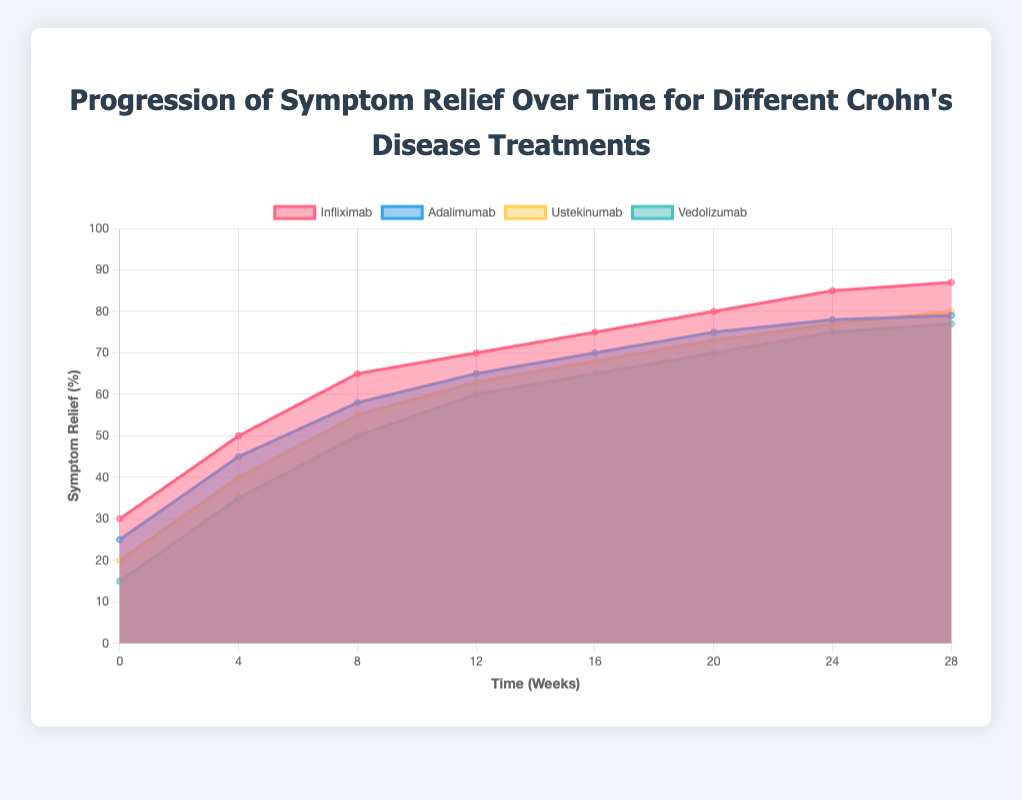What is the title of the figure? The title of the figure is displayed at the top of the chart.
Answer: "Progression of Symptom Relief Over Time for Different Crohn's Disease Treatments" Which treatment shows the highest symptom relief at week 28? By looking at the values at week 28 for all treatments, Infliximab shows the highest symptom relief.
Answer: Infliximab How many weeks are represented on the x-axis? The x-axis lists the weeks at various time intervals. The points are 0, 4, 8, 12, 16, 20, 24, and 28, which totals to 8 points.
Answer: 8 weeks What is the symptom relief percentage for Vedolizumab at week 12? The value for Vedolizumab at week 12 can be directly read from its line on the chart.
Answer: 60% Which treatment has the least symptom relief at week 4? By comparing the values at week 4 for all treatments, Vedolizumab has the least symptom relief.
Answer: Vedolizumab By how much does Infliximab's symptom relief increase from week 0 to week 4? Subtract the symptom relief percentage at week 0 from that at week 4: 50 - 30 = 20%.
Answer: 20% What is the average symptom relief for Ustekinumab across all weeks shown? Sum the percentages for Ustekinumab and then divide by the number of weeks: (20 + 40 + 55 + 63 + 68 + 73 + 77 + 80) / 8 = 59.5%.
Answer: 59.5% At which week do Adalimumab and Vedolizumab have the same symptom relief percentage? Look for the intersection of Adalimumab and Vedolizumab lines on the chart. They intersect at week 8, both showing 50% symptom relief.
Answer: Week 8 Which treatment shows a constant or steady increase in symptom relief without any plateau? By observing all lines, Infliximab has a steady increase without any noticeable plateau.
Answer: Infliximab Between which weeks does Vedolizumab show the largest increase in symptom relief percentage? Calculate the differences between weeks for Vedolizumab and find the largest increase: largest difference is 15%, between week 8 (50%) and week 12 (60%).
Answer: Week 8 to Week 12 